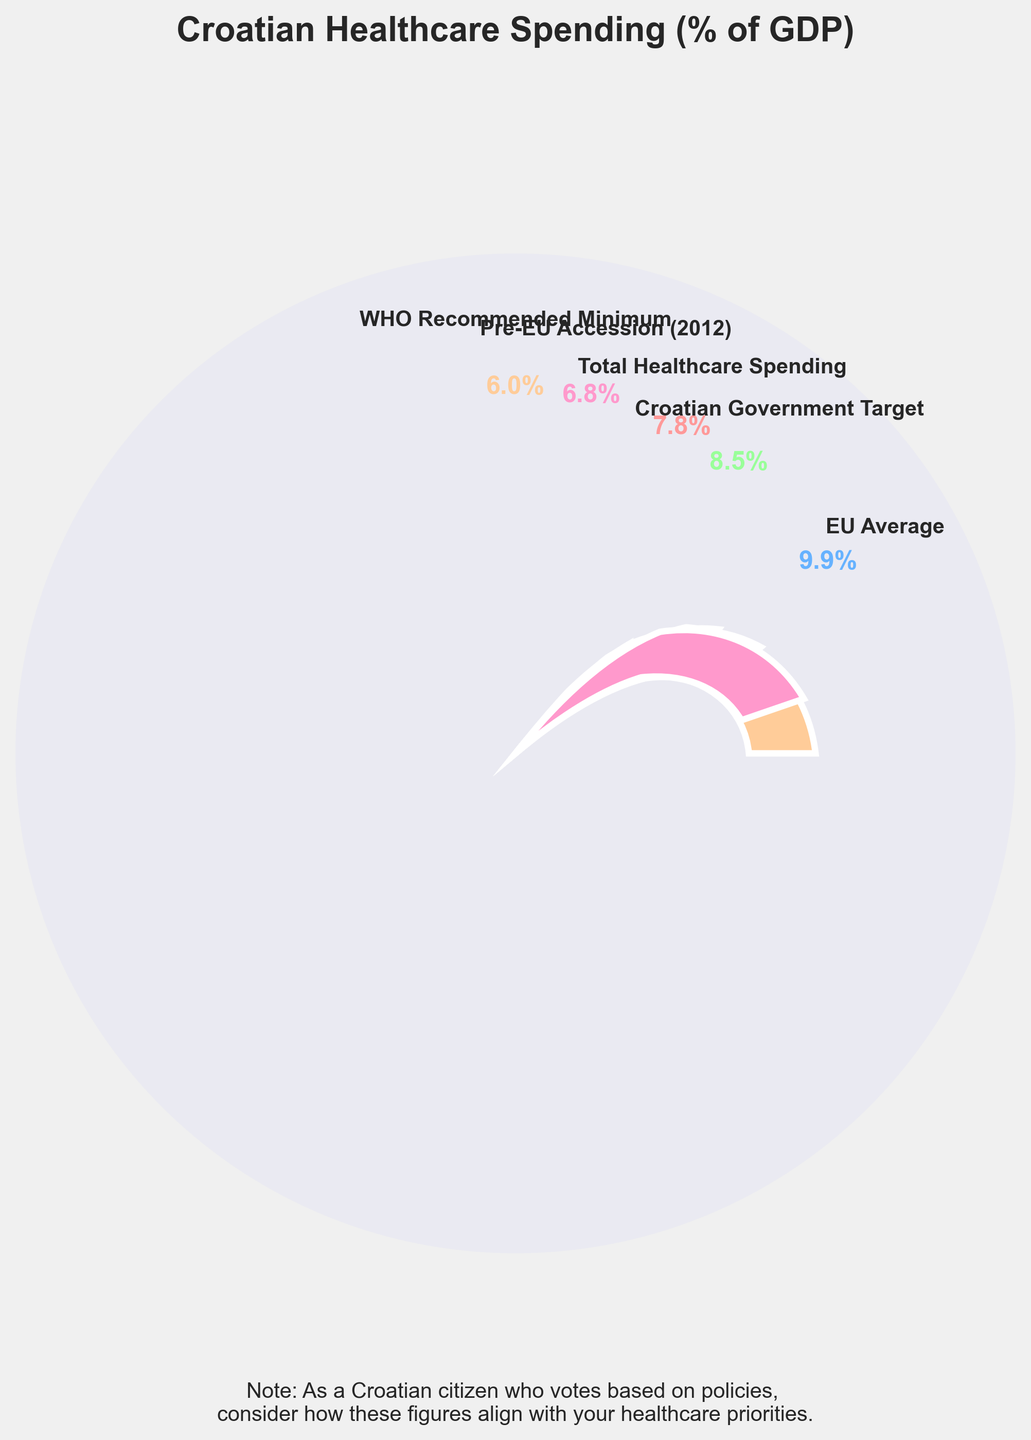What is the percentage of GDP allocated to total healthcare spending in Croatia? The gauge shows that the percentage indicated for Total Healthcare Spending is 7.8% of GDP.
Answer: 7.8% How does Croatia’s total healthcare spending as a percentage of GDP compare with the EU average? The EU average healthcare spending is shown as 9.9%, while Croatia’s total healthcare spending is 7.8%. Therefore, Croatia spends less than the EU average.
Answer: Less than What is the percentage difference between Croatia's healthcare spending and the WHO recommended minimum? The WHO recommended minimum is 6.0%, and Croatia's spending is 7.8%. The percentage difference is 7.8% - 6.0%.
Answer: 1.8% Is Croatia's healthcare spending above the pre-EU accession level? The percentage for Pre-EU Accession (2012) healthcare spending is shown as 6.8%, while the current spending is 7.8%. Therefore, current spending is above the pre-EU accession level.
Answer: Yes Which spending target or benchmark is Croatia closest to achieving? Croatia’s total healthcare spending is 7.8%, the closest target to this is the Croatian Government Target at 8.5%.
Answer: Croatian Government Target What is the difference between Croatia's current healthcare spending and the government target? Croatia's current healthcare spending is 7.8%, and the government's target is 8.5%. The difference is 8.5% - 7.8%.
Answer: 0.7% Does Croatia meet the WHO recommended minimum healthcare spending? The WHO recommended minimum is 6.0%, and Croatia's current spending is 7.8%, which is above the minimum.
Answer: Yes Rank the listed healthcare spending percentages from highest to lowest. The percentages are: EU Average - 9.9%, Croatian Government Target - 8.5%, Total Healthcare Spending - 7.8%, Pre-EU Accession (2012) - 6.8%, WHO Recommended Minimum - 6.0%.
Answer: EU Average, Croatian Government Target, Total Healthcare Spending, Pre-EU Accession (2012), WHO Recommended Minimum How much more does the EU average spend on healthcare compared to Croatia? The EU Average is 9.9% and Croatia's spending is 7.8%. The EU spends 9.9% - 7.8% more.
Answer: 2.1% Does the figure include the exact percentage value for the Croatian government target for healthcare spending? Yes, the gauge indicates the Croatian Government Target as 8.5%.
Answer: Yes 